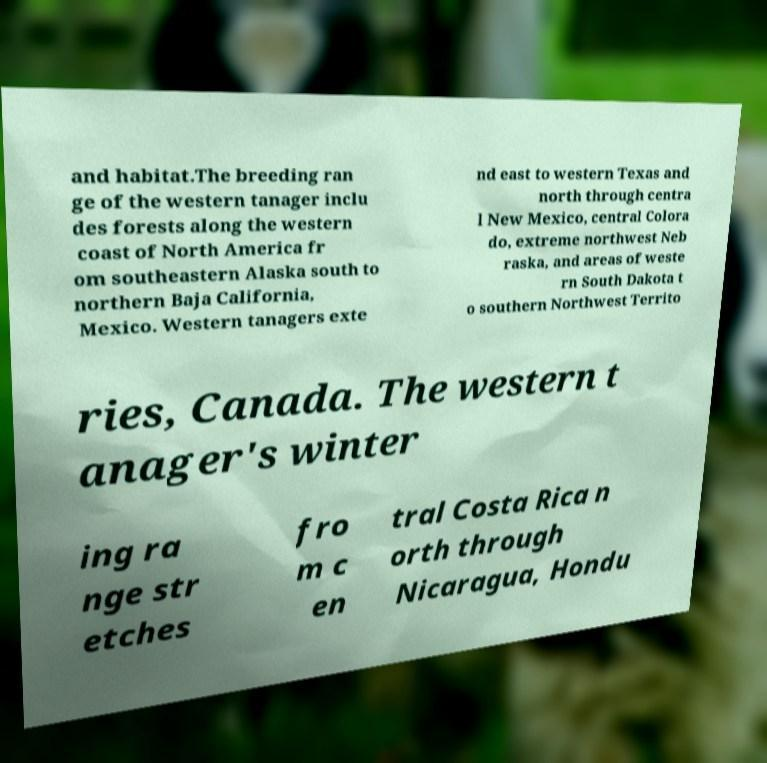Please identify and transcribe the text found in this image. and habitat.The breeding ran ge of the western tanager inclu des forests along the western coast of North America fr om southeastern Alaska south to northern Baja California, Mexico. Western tanagers exte nd east to western Texas and north through centra l New Mexico, central Colora do, extreme northwest Neb raska, and areas of weste rn South Dakota t o southern Northwest Territo ries, Canada. The western t anager's winter ing ra nge str etches fro m c en tral Costa Rica n orth through Nicaragua, Hondu 